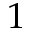<formula> <loc_0><loc_0><loc_500><loc_500>1</formula> 